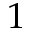<formula> <loc_0><loc_0><loc_500><loc_500>1</formula> 